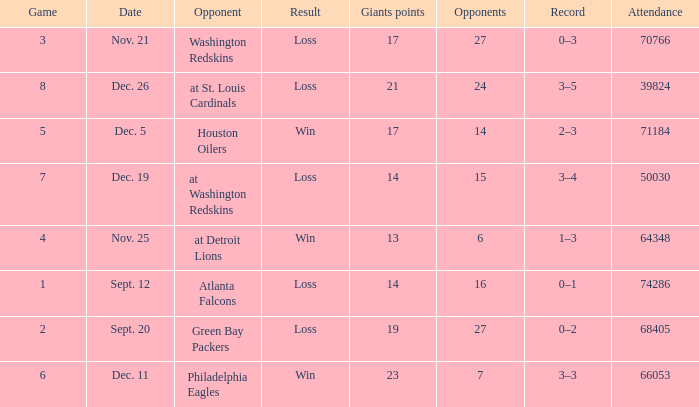What is the minimum number of opponents? 6.0. 